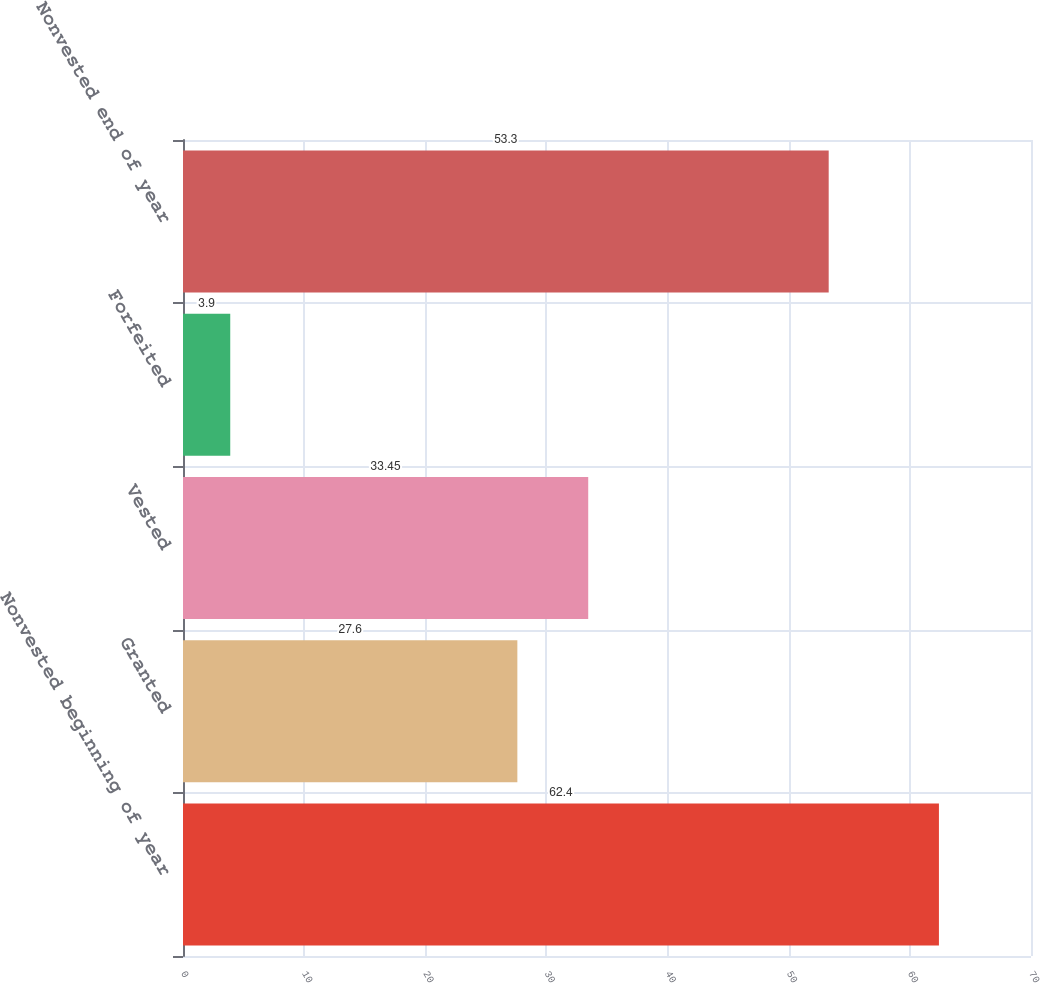<chart> <loc_0><loc_0><loc_500><loc_500><bar_chart><fcel>Nonvested beginning of year<fcel>Granted<fcel>Vested<fcel>Forfeited<fcel>Nonvested end of year<nl><fcel>62.4<fcel>27.6<fcel>33.45<fcel>3.9<fcel>53.3<nl></chart> 